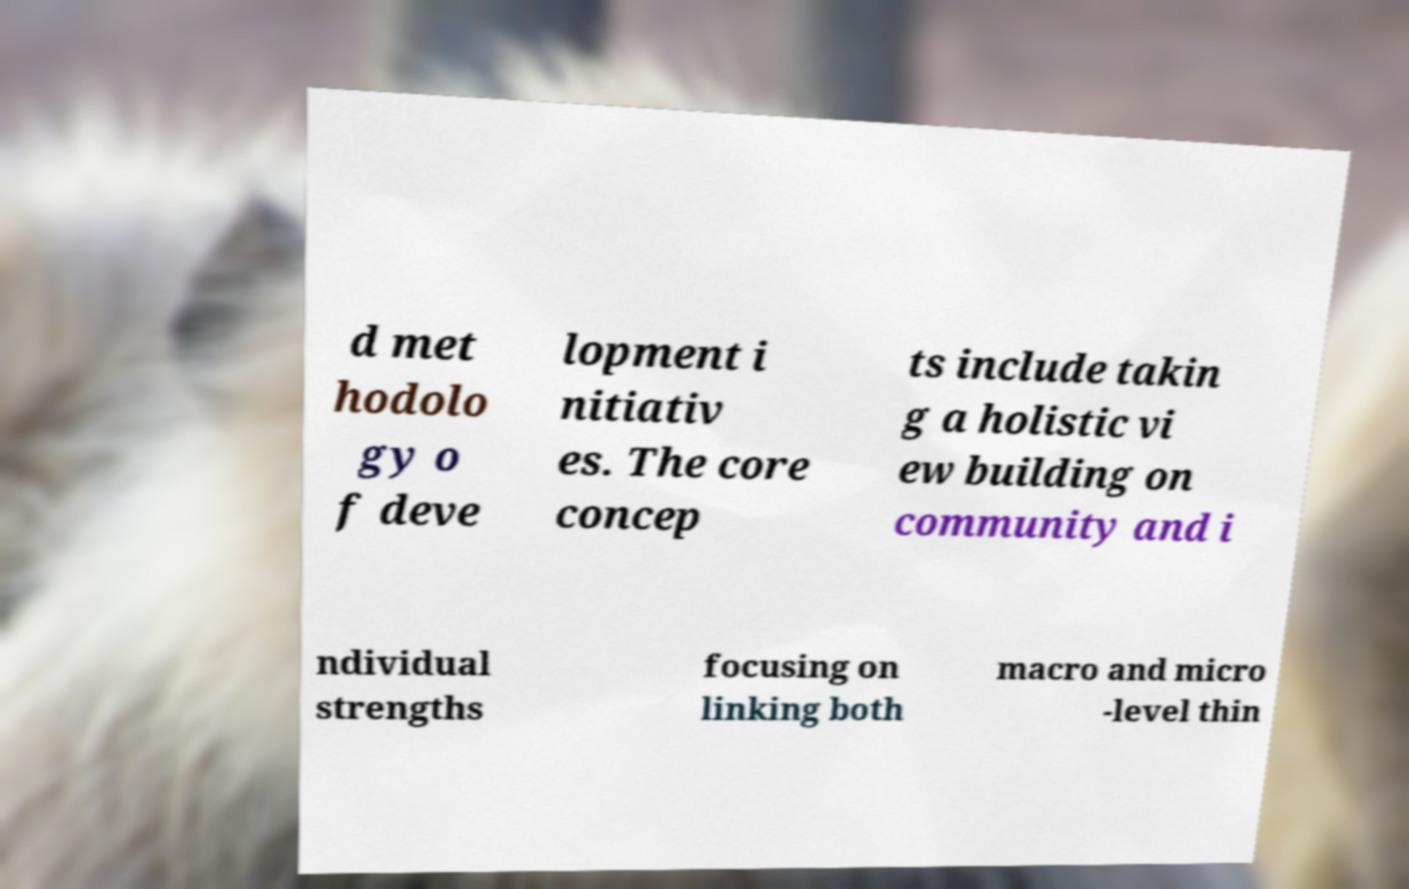Could you assist in decoding the text presented in this image and type it out clearly? d met hodolo gy o f deve lopment i nitiativ es. The core concep ts include takin g a holistic vi ew building on community and i ndividual strengths focusing on linking both macro and micro -level thin 